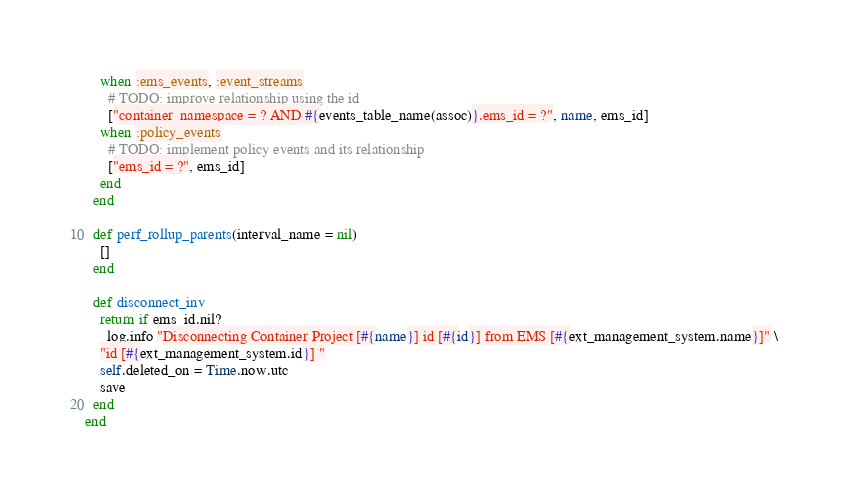<code> <loc_0><loc_0><loc_500><loc_500><_Ruby_>    when :ems_events, :event_streams
      # TODO: improve relationship using the id
      ["container_namespace = ? AND #{events_table_name(assoc)}.ems_id = ?", name, ems_id]
    when :policy_events
      # TODO: implement policy events and its relationship
      ["ems_id = ?", ems_id]
    end
  end

  def perf_rollup_parents(interval_name = nil)
    []
  end

  def disconnect_inv
    return if ems_id.nil?
    _log.info "Disconnecting Container Project [#{name}] id [#{id}] from EMS [#{ext_management_system.name}]" \
    "id [#{ext_management_system.id}] "
    self.deleted_on = Time.now.utc
    save
  end
end
</code> 